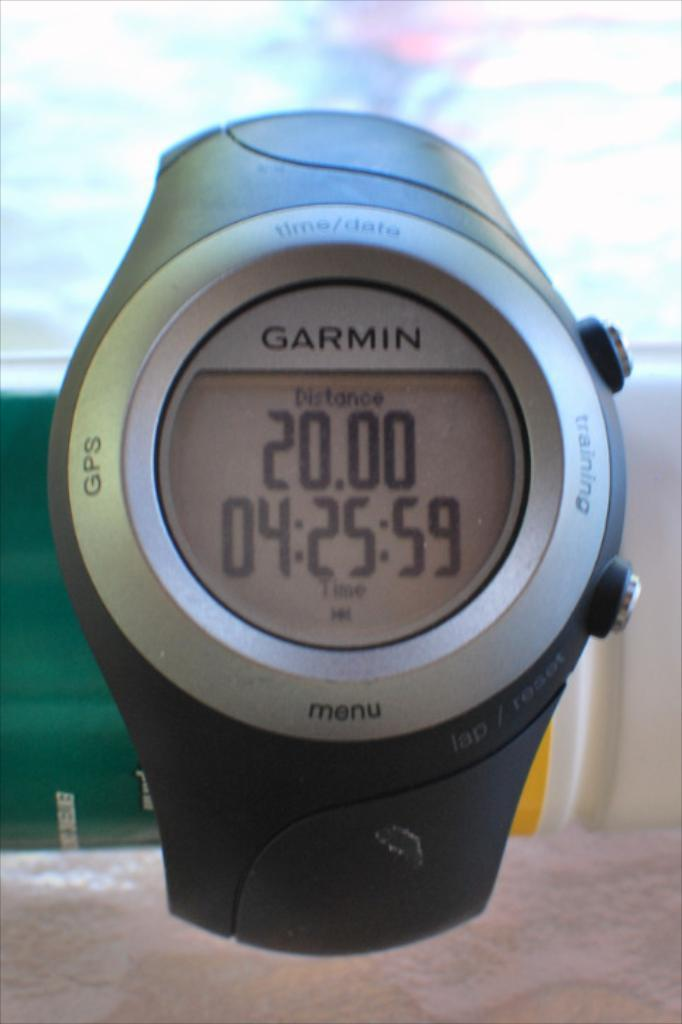<image>
Render a clear and concise summary of the photo. Distance of 20 is displayed on this Garmin smart watch. 